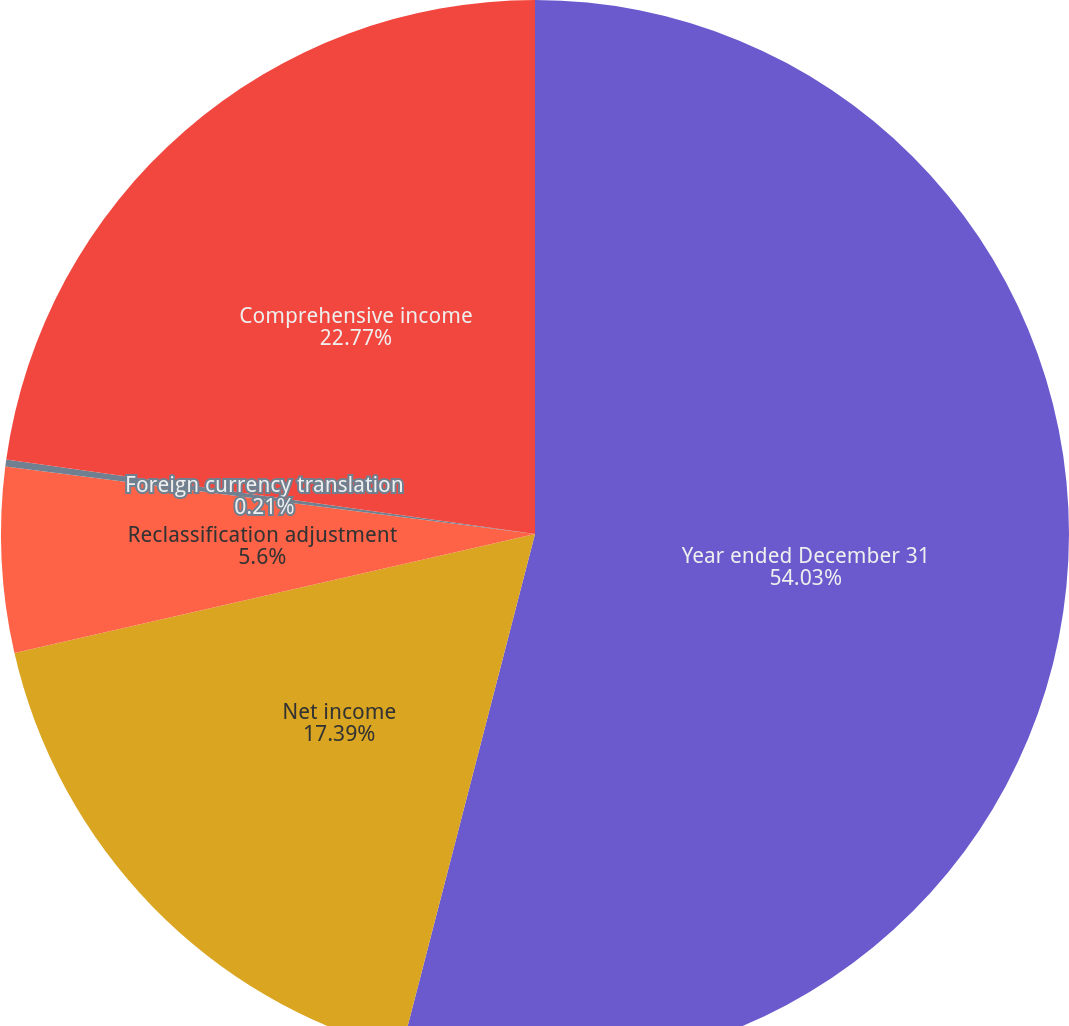Convert chart to OTSL. <chart><loc_0><loc_0><loc_500><loc_500><pie_chart><fcel>Year ended December 31<fcel>Net income<fcel>Reclassification adjustment<fcel>Foreign currency translation<fcel>Comprehensive income<nl><fcel>54.03%<fcel>17.39%<fcel>5.6%<fcel>0.21%<fcel>22.77%<nl></chart> 